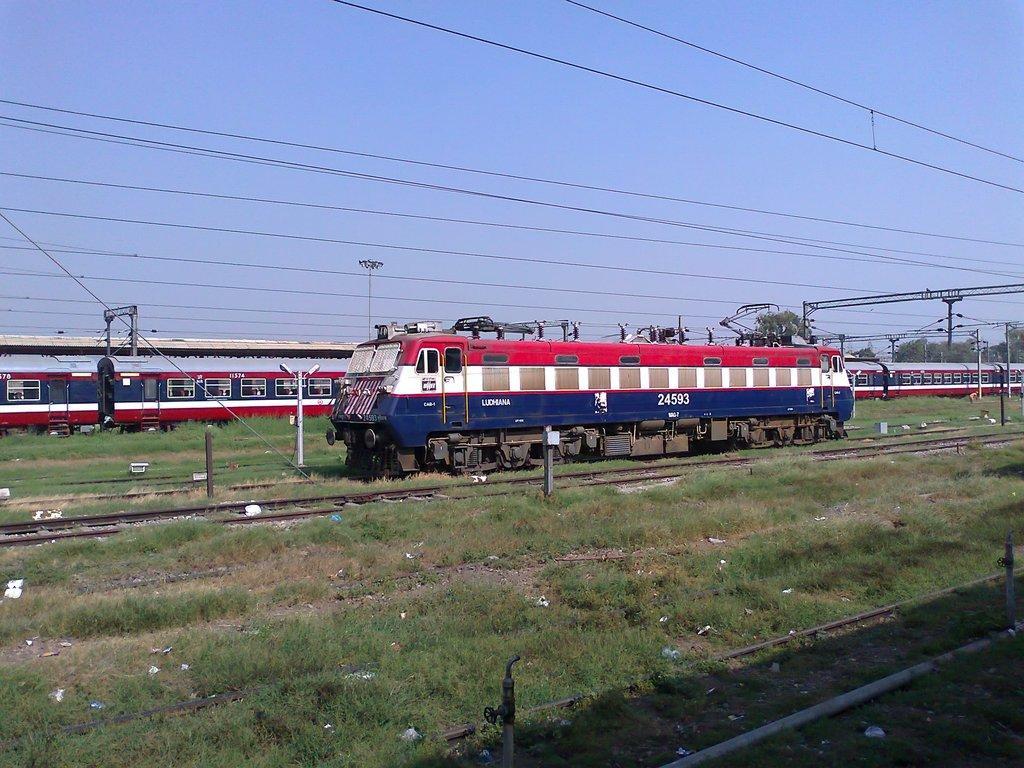Could you give a brief overview of what you see in this image? In the center of the image there is a train engine on the railway track. In the background of the image there is a train. There are wires,trees. At the top of the image there is sky. At the bottom of the image there is grass. There is a pipe. 